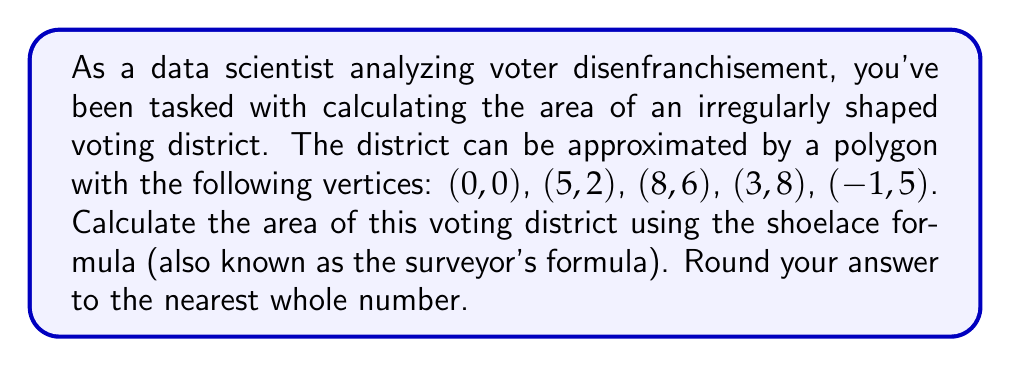Teach me how to tackle this problem. To solve this problem, we'll use the shoelace formula, which is particularly useful for calculating the area of irregular polygons. The formula is:

$$ A = \frac{1}{2}\left|\sum_{i=1}^{n-1} (x_i y_{i+1} + x_n y_1) - \sum_{i=1}^{n-1} (y_i x_{i+1} + y_n x_1)\right| $$

Where $(x_i, y_i)$ are the coordinates of the $i$-th vertex, and $n$ is the number of vertices.

Let's apply this to our polygon:

1) First, let's list our vertices in order:
   $(x_1, y_1) = (0, 0)$
   $(x_2, y_2) = (5, 2)$
   $(x_3, y_3) = (8, 6)$
   $(x_4, y_4) = (3, 8)$
   $(x_5, y_5) = (-1, 5)$

2) Now, let's calculate the first sum:
   $\sum_{i=1}^{n-1} (x_i y_{i+1} + x_n y_1) = (0 \cdot 2 + 5 \cdot 6 + 8 \cdot 8 + 3 \cdot 5 + (-1) \cdot 0) = 0 + 30 + 64 + 15 + 0 = 109$

3) Next, the second sum:
   $\sum_{i=1}^{n-1} (y_i x_{i+1} + y_n x_1) = (0 \cdot 5 + 2 \cdot 8 + 6 \cdot 3 + 8 \cdot (-1) + 5 \cdot 0) = 0 + 16 + 18 - 8 + 0 = 26$

4) Now we can subtract and take the absolute value:
   $|109 - 26| = 83$

5) Finally, we multiply by 1/2:
   $\frac{1}{2} \cdot 83 = 41.5$

6) Rounding to the nearest whole number:
   $41.5 \approx 42$

Therefore, the area of the voting district is approximately 42 square units.
Answer: 42 square units 